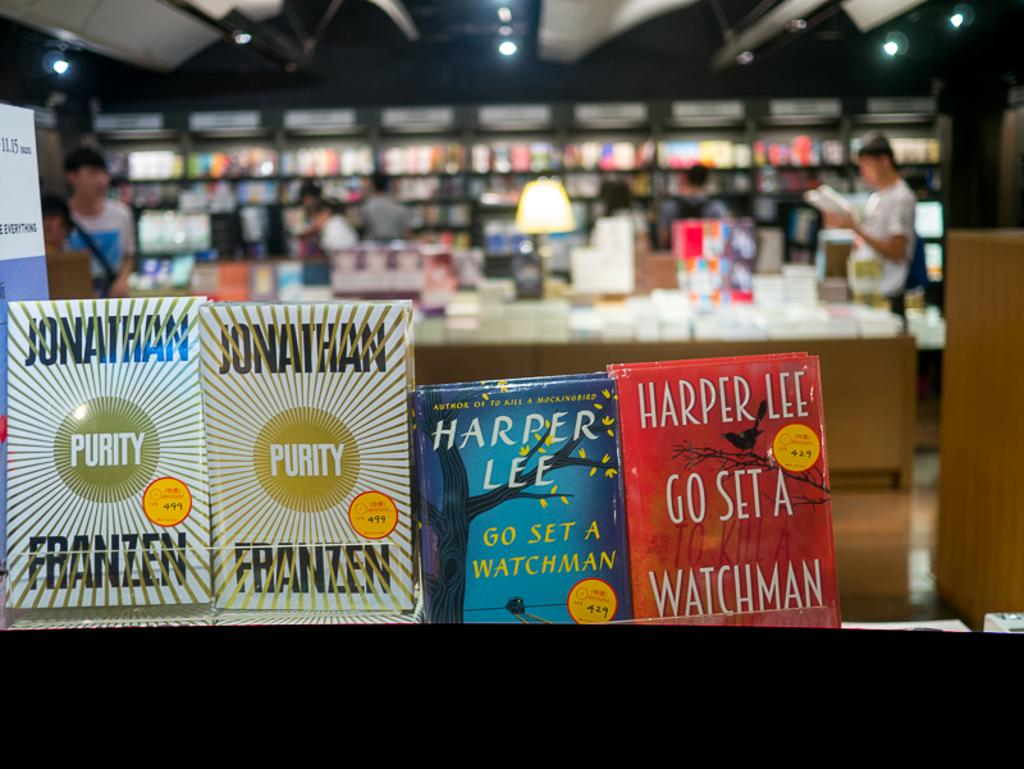Provide a one-sentence caption for the provided image. books in a bookshop including Purity and Harper Lee. 